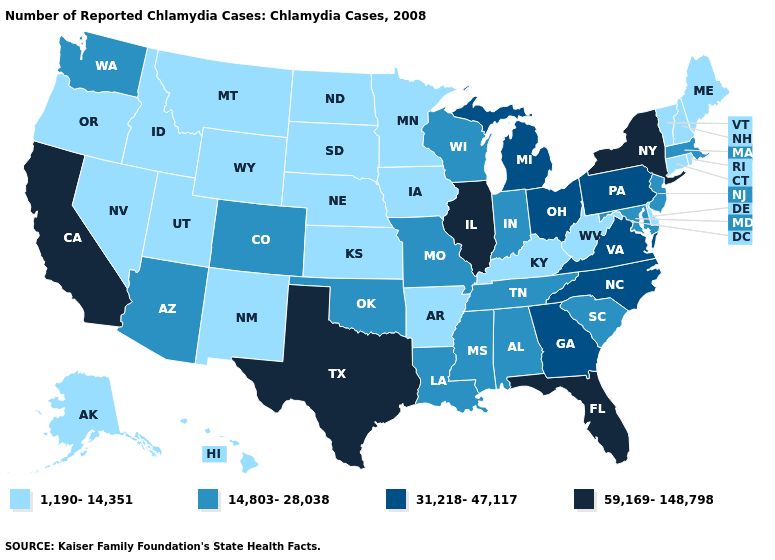Name the states that have a value in the range 31,218-47,117?
Concise answer only. Georgia, Michigan, North Carolina, Ohio, Pennsylvania, Virginia. What is the value of New Hampshire?
Quick response, please. 1,190-14,351. Does Minnesota have a lower value than Rhode Island?
Keep it brief. No. Which states have the lowest value in the USA?
Give a very brief answer. Alaska, Arkansas, Connecticut, Delaware, Hawaii, Idaho, Iowa, Kansas, Kentucky, Maine, Minnesota, Montana, Nebraska, Nevada, New Hampshire, New Mexico, North Dakota, Oregon, Rhode Island, South Dakota, Utah, Vermont, West Virginia, Wyoming. Does Connecticut have the lowest value in the USA?
Short answer required. Yes. Name the states that have a value in the range 14,803-28,038?
Quick response, please. Alabama, Arizona, Colorado, Indiana, Louisiana, Maryland, Massachusetts, Mississippi, Missouri, New Jersey, Oklahoma, South Carolina, Tennessee, Washington, Wisconsin. Does the map have missing data?
Answer briefly. No. Which states have the highest value in the USA?
Keep it brief. California, Florida, Illinois, New York, Texas. What is the value of Ohio?
Answer briefly. 31,218-47,117. What is the lowest value in the USA?
Short answer required. 1,190-14,351. Name the states that have a value in the range 59,169-148,798?
Keep it brief. California, Florida, Illinois, New York, Texas. Does Arizona have the lowest value in the USA?
Concise answer only. No. Does Iowa have the same value as Washington?
Short answer required. No. Does the first symbol in the legend represent the smallest category?
Be succinct. Yes. Does Alabama have a lower value than South Carolina?
Keep it brief. No. 